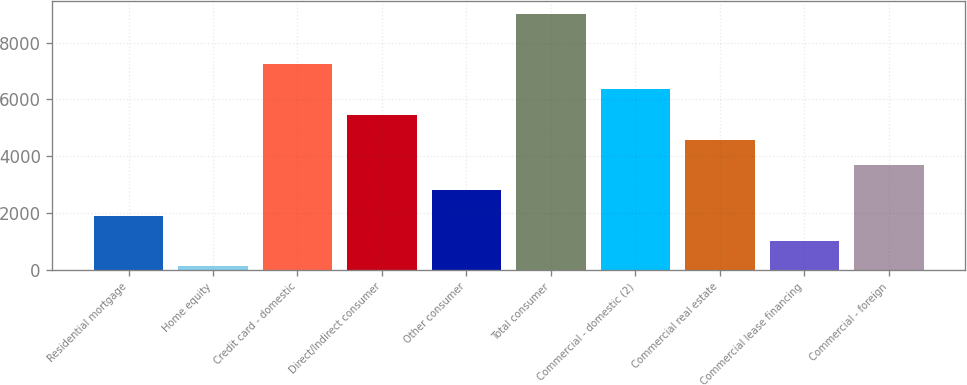<chart> <loc_0><loc_0><loc_500><loc_500><bar_chart><fcel>Residential mortgage<fcel>Home equity<fcel>Credit card - domestic<fcel>Direct/Indirect consumer<fcel>Other consumer<fcel>Total consumer<fcel>Commercial - domestic (2)<fcel>Commercial real estate<fcel>Commercial lease financing<fcel>Commercial - foreign<nl><fcel>1909.6<fcel>133<fcel>7239.4<fcel>5462.8<fcel>2797.9<fcel>9016<fcel>6351.1<fcel>4574.5<fcel>1021.3<fcel>3686.2<nl></chart> 